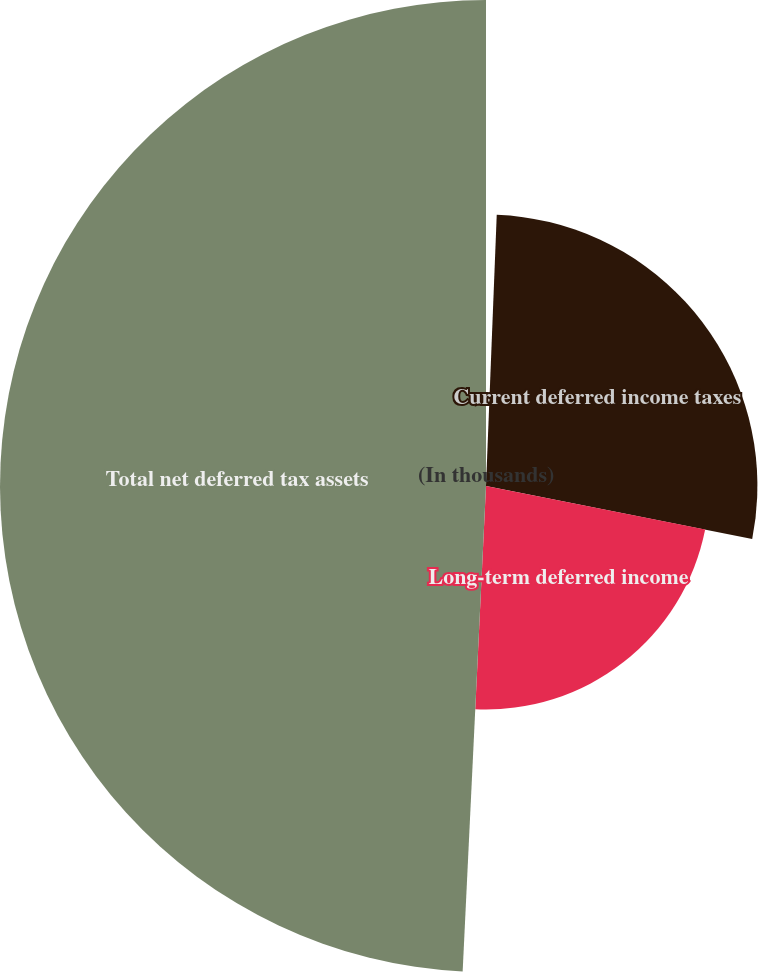<chart> <loc_0><loc_0><loc_500><loc_500><pie_chart><fcel>(In thousands)<fcel>Current deferred income taxes<fcel>Long-term deferred income<fcel>Total net deferred tax assets<nl><fcel>0.63%<fcel>27.5%<fcel>22.64%<fcel>49.24%<nl></chart> 